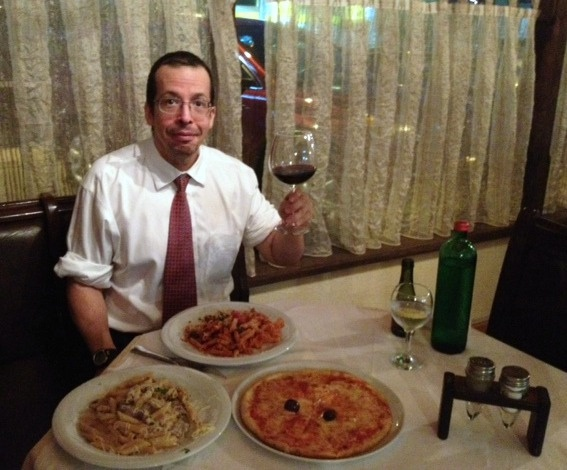Describe the objects in this image and their specific colors. I can see dining table in gray, maroon, and black tones, people in gray, lightgray, maroon, and darkgray tones, chair in gray and black tones, pizza in gray, maroon, and brown tones, and chair in gray and black tones in this image. 